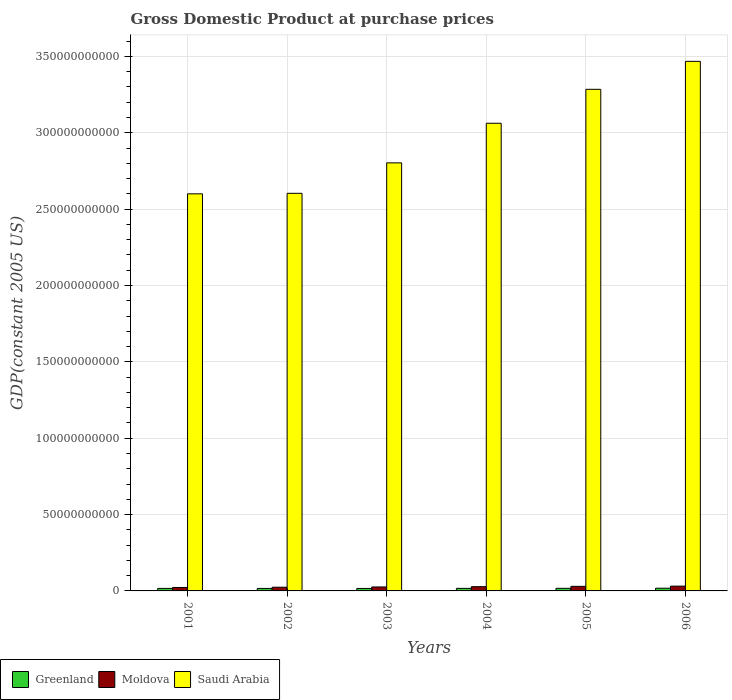How many different coloured bars are there?
Provide a succinct answer. 3. How many groups of bars are there?
Make the answer very short. 6. Are the number of bars per tick equal to the number of legend labels?
Offer a terse response. Yes. What is the label of the 3rd group of bars from the left?
Offer a terse response. 2003. In how many cases, is the number of bars for a given year not equal to the number of legend labels?
Provide a short and direct response. 0. What is the GDP at purchase prices in Moldova in 2005?
Give a very brief answer. 2.99e+09. Across all years, what is the maximum GDP at purchase prices in Saudi Arabia?
Provide a short and direct response. 3.47e+11. Across all years, what is the minimum GDP at purchase prices in Moldova?
Offer a very short reply. 2.25e+09. In which year was the GDP at purchase prices in Greenland maximum?
Offer a terse response. 2006. In which year was the GDP at purchase prices in Greenland minimum?
Provide a succinct answer. 2003. What is the total GDP at purchase prices in Saudi Arabia in the graph?
Give a very brief answer. 1.78e+12. What is the difference between the GDP at purchase prices in Saudi Arabia in 2003 and that in 2005?
Your answer should be very brief. -4.82e+1. What is the difference between the GDP at purchase prices in Greenland in 2006 and the GDP at purchase prices in Moldova in 2002?
Your answer should be compact. -6.49e+08. What is the average GDP at purchase prices in Greenland per year?
Your answer should be compact. 1.68e+09. In the year 2003, what is the difference between the GDP at purchase prices in Saudi Arabia and GDP at purchase prices in Greenland?
Provide a short and direct response. 2.79e+11. What is the ratio of the GDP at purchase prices in Moldova in 2001 to that in 2002?
Give a very brief answer. 0.93. Is the difference between the GDP at purchase prices in Saudi Arabia in 2001 and 2003 greater than the difference between the GDP at purchase prices in Greenland in 2001 and 2003?
Provide a short and direct response. No. What is the difference between the highest and the second highest GDP at purchase prices in Greenland?
Offer a very short reply. 7.61e+07. What is the difference between the highest and the lowest GDP at purchase prices in Moldova?
Offer a very short reply. 8.79e+08. In how many years, is the GDP at purchase prices in Moldova greater than the average GDP at purchase prices in Moldova taken over all years?
Ensure brevity in your answer.  3. What does the 2nd bar from the left in 2006 represents?
Your response must be concise. Moldova. What does the 2nd bar from the right in 2003 represents?
Provide a succinct answer. Moldova. How many bars are there?
Keep it short and to the point. 18. Are all the bars in the graph horizontal?
Give a very brief answer. No. How many years are there in the graph?
Keep it short and to the point. 6. Are the values on the major ticks of Y-axis written in scientific E-notation?
Ensure brevity in your answer.  No. Does the graph contain grids?
Ensure brevity in your answer.  Yes. Where does the legend appear in the graph?
Keep it short and to the point. Bottom left. How are the legend labels stacked?
Your answer should be very brief. Horizontal. What is the title of the graph?
Keep it short and to the point. Gross Domestic Product at purchase prices. Does "Iran" appear as one of the legend labels in the graph?
Give a very brief answer. No. What is the label or title of the Y-axis?
Your response must be concise. GDP(constant 2005 US). What is the GDP(constant 2005 US) of Greenland in 2001?
Give a very brief answer. 1.65e+09. What is the GDP(constant 2005 US) in Moldova in 2001?
Offer a very short reply. 2.25e+09. What is the GDP(constant 2005 US) of Saudi Arabia in 2001?
Your answer should be very brief. 2.60e+11. What is the GDP(constant 2005 US) in Greenland in 2002?
Make the answer very short. 1.63e+09. What is the GDP(constant 2005 US) in Moldova in 2002?
Make the answer very short. 2.43e+09. What is the GDP(constant 2005 US) of Saudi Arabia in 2002?
Make the answer very short. 2.60e+11. What is the GDP(constant 2005 US) of Greenland in 2003?
Your answer should be very brief. 1.63e+09. What is the GDP(constant 2005 US) of Moldova in 2003?
Ensure brevity in your answer.  2.59e+09. What is the GDP(constant 2005 US) of Saudi Arabia in 2003?
Provide a short and direct response. 2.80e+11. What is the GDP(constant 2005 US) of Greenland in 2004?
Make the answer very short. 1.67e+09. What is the GDP(constant 2005 US) of Moldova in 2004?
Your response must be concise. 2.78e+09. What is the GDP(constant 2005 US) of Saudi Arabia in 2004?
Offer a very short reply. 3.06e+11. What is the GDP(constant 2005 US) of Greenland in 2005?
Provide a short and direct response. 1.70e+09. What is the GDP(constant 2005 US) of Moldova in 2005?
Offer a very short reply. 2.99e+09. What is the GDP(constant 2005 US) of Saudi Arabia in 2005?
Your answer should be compact. 3.28e+11. What is the GDP(constant 2005 US) of Greenland in 2006?
Your response must be concise. 1.78e+09. What is the GDP(constant 2005 US) of Moldova in 2006?
Your answer should be compact. 3.13e+09. What is the GDP(constant 2005 US) in Saudi Arabia in 2006?
Make the answer very short. 3.47e+11. Across all years, what is the maximum GDP(constant 2005 US) in Greenland?
Give a very brief answer. 1.78e+09. Across all years, what is the maximum GDP(constant 2005 US) in Moldova?
Offer a very short reply. 3.13e+09. Across all years, what is the maximum GDP(constant 2005 US) in Saudi Arabia?
Ensure brevity in your answer.  3.47e+11. Across all years, what is the minimum GDP(constant 2005 US) in Greenland?
Give a very brief answer. 1.63e+09. Across all years, what is the minimum GDP(constant 2005 US) of Moldova?
Your response must be concise. 2.25e+09. Across all years, what is the minimum GDP(constant 2005 US) of Saudi Arabia?
Your answer should be very brief. 2.60e+11. What is the total GDP(constant 2005 US) in Greenland in the graph?
Your response must be concise. 1.01e+1. What is the total GDP(constant 2005 US) in Moldova in the graph?
Offer a terse response. 1.62e+1. What is the total GDP(constant 2005 US) of Saudi Arabia in the graph?
Offer a very short reply. 1.78e+12. What is the difference between the GDP(constant 2005 US) of Greenland in 2001 and that in 2002?
Provide a succinct answer. 1.60e+07. What is the difference between the GDP(constant 2005 US) in Moldova in 2001 and that in 2002?
Your answer should be compact. -1.76e+08. What is the difference between the GDP(constant 2005 US) in Saudi Arabia in 2001 and that in 2002?
Your answer should be compact. -3.32e+08. What is the difference between the GDP(constant 2005 US) in Greenland in 2001 and that in 2003?
Your response must be concise. 2.22e+07. What is the difference between the GDP(constant 2005 US) of Moldova in 2001 and that in 2003?
Provide a succinct answer. -3.36e+08. What is the difference between the GDP(constant 2005 US) in Saudi Arabia in 2001 and that in 2003?
Offer a terse response. -2.03e+1. What is the difference between the GDP(constant 2005 US) of Greenland in 2001 and that in 2004?
Offer a very short reply. -2.12e+07. What is the difference between the GDP(constant 2005 US) in Moldova in 2001 and that in 2004?
Keep it short and to the point. -5.28e+08. What is the difference between the GDP(constant 2005 US) in Saudi Arabia in 2001 and that in 2004?
Your answer should be very brief. -4.62e+1. What is the difference between the GDP(constant 2005 US) in Greenland in 2001 and that in 2005?
Your answer should be very brief. -5.42e+07. What is the difference between the GDP(constant 2005 US) of Moldova in 2001 and that in 2005?
Make the answer very short. -7.36e+08. What is the difference between the GDP(constant 2005 US) in Saudi Arabia in 2001 and that in 2005?
Offer a very short reply. -6.84e+1. What is the difference between the GDP(constant 2005 US) of Greenland in 2001 and that in 2006?
Make the answer very short. -1.30e+08. What is the difference between the GDP(constant 2005 US) in Moldova in 2001 and that in 2006?
Make the answer very short. -8.79e+08. What is the difference between the GDP(constant 2005 US) in Saudi Arabia in 2001 and that in 2006?
Provide a succinct answer. -8.68e+1. What is the difference between the GDP(constant 2005 US) in Greenland in 2002 and that in 2003?
Offer a terse response. 6.20e+06. What is the difference between the GDP(constant 2005 US) of Moldova in 2002 and that in 2003?
Ensure brevity in your answer.  -1.60e+08. What is the difference between the GDP(constant 2005 US) of Saudi Arabia in 2002 and that in 2003?
Ensure brevity in your answer.  -1.99e+1. What is the difference between the GDP(constant 2005 US) of Greenland in 2002 and that in 2004?
Your response must be concise. -3.72e+07. What is the difference between the GDP(constant 2005 US) in Moldova in 2002 and that in 2004?
Offer a very short reply. -3.52e+08. What is the difference between the GDP(constant 2005 US) of Saudi Arabia in 2002 and that in 2004?
Give a very brief answer. -4.59e+1. What is the difference between the GDP(constant 2005 US) in Greenland in 2002 and that in 2005?
Keep it short and to the point. -7.02e+07. What is the difference between the GDP(constant 2005 US) of Moldova in 2002 and that in 2005?
Provide a short and direct response. -5.60e+08. What is the difference between the GDP(constant 2005 US) of Saudi Arabia in 2002 and that in 2005?
Provide a succinct answer. -6.81e+1. What is the difference between the GDP(constant 2005 US) in Greenland in 2002 and that in 2006?
Make the answer very short. -1.46e+08. What is the difference between the GDP(constant 2005 US) in Moldova in 2002 and that in 2006?
Give a very brief answer. -7.04e+08. What is the difference between the GDP(constant 2005 US) of Saudi Arabia in 2002 and that in 2006?
Provide a short and direct response. -8.64e+1. What is the difference between the GDP(constant 2005 US) in Greenland in 2003 and that in 2004?
Ensure brevity in your answer.  -4.34e+07. What is the difference between the GDP(constant 2005 US) in Moldova in 2003 and that in 2004?
Ensure brevity in your answer.  -1.92e+08. What is the difference between the GDP(constant 2005 US) of Saudi Arabia in 2003 and that in 2004?
Keep it short and to the point. -2.59e+1. What is the difference between the GDP(constant 2005 US) in Greenland in 2003 and that in 2005?
Provide a succinct answer. -7.64e+07. What is the difference between the GDP(constant 2005 US) of Moldova in 2003 and that in 2005?
Ensure brevity in your answer.  -4.00e+08. What is the difference between the GDP(constant 2005 US) of Saudi Arabia in 2003 and that in 2005?
Your response must be concise. -4.82e+1. What is the difference between the GDP(constant 2005 US) of Greenland in 2003 and that in 2006?
Offer a terse response. -1.53e+08. What is the difference between the GDP(constant 2005 US) of Moldova in 2003 and that in 2006?
Ensure brevity in your answer.  -5.43e+08. What is the difference between the GDP(constant 2005 US) of Saudi Arabia in 2003 and that in 2006?
Provide a succinct answer. -6.65e+1. What is the difference between the GDP(constant 2005 US) in Greenland in 2004 and that in 2005?
Your answer should be very brief. -3.30e+07. What is the difference between the GDP(constant 2005 US) in Moldova in 2004 and that in 2005?
Your response must be concise. -2.08e+08. What is the difference between the GDP(constant 2005 US) in Saudi Arabia in 2004 and that in 2005?
Offer a terse response. -2.22e+1. What is the difference between the GDP(constant 2005 US) of Greenland in 2004 and that in 2006?
Offer a terse response. -1.09e+08. What is the difference between the GDP(constant 2005 US) of Moldova in 2004 and that in 2006?
Offer a very short reply. -3.52e+08. What is the difference between the GDP(constant 2005 US) in Saudi Arabia in 2004 and that in 2006?
Your answer should be compact. -4.05e+1. What is the difference between the GDP(constant 2005 US) of Greenland in 2005 and that in 2006?
Your answer should be compact. -7.61e+07. What is the difference between the GDP(constant 2005 US) in Moldova in 2005 and that in 2006?
Provide a succinct answer. -1.43e+08. What is the difference between the GDP(constant 2005 US) of Saudi Arabia in 2005 and that in 2006?
Ensure brevity in your answer.  -1.83e+1. What is the difference between the GDP(constant 2005 US) in Greenland in 2001 and the GDP(constant 2005 US) in Moldova in 2002?
Your answer should be compact. -7.80e+08. What is the difference between the GDP(constant 2005 US) of Greenland in 2001 and the GDP(constant 2005 US) of Saudi Arabia in 2002?
Ensure brevity in your answer.  -2.59e+11. What is the difference between the GDP(constant 2005 US) of Moldova in 2001 and the GDP(constant 2005 US) of Saudi Arabia in 2002?
Ensure brevity in your answer.  -2.58e+11. What is the difference between the GDP(constant 2005 US) in Greenland in 2001 and the GDP(constant 2005 US) in Moldova in 2003?
Offer a terse response. -9.40e+08. What is the difference between the GDP(constant 2005 US) of Greenland in 2001 and the GDP(constant 2005 US) of Saudi Arabia in 2003?
Your answer should be very brief. -2.79e+11. What is the difference between the GDP(constant 2005 US) in Moldova in 2001 and the GDP(constant 2005 US) in Saudi Arabia in 2003?
Your response must be concise. -2.78e+11. What is the difference between the GDP(constant 2005 US) of Greenland in 2001 and the GDP(constant 2005 US) of Moldova in 2004?
Ensure brevity in your answer.  -1.13e+09. What is the difference between the GDP(constant 2005 US) of Greenland in 2001 and the GDP(constant 2005 US) of Saudi Arabia in 2004?
Give a very brief answer. -3.05e+11. What is the difference between the GDP(constant 2005 US) in Moldova in 2001 and the GDP(constant 2005 US) in Saudi Arabia in 2004?
Your answer should be very brief. -3.04e+11. What is the difference between the GDP(constant 2005 US) in Greenland in 2001 and the GDP(constant 2005 US) in Moldova in 2005?
Your answer should be very brief. -1.34e+09. What is the difference between the GDP(constant 2005 US) of Greenland in 2001 and the GDP(constant 2005 US) of Saudi Arabia in 2005?
Offer a terse response. -3.27e+11. What is the difference between the GDP(constant 2005 US) in Moldova in 2001 and the GDP(constant 2005 US) in Saudi Arabia in 2005?
Keep it short and to the point. -3.26e+11. What is the difference between the GDP(constant 2005 US) in Greenland in 2001 and the GDP(constant 2005 US) in Moldova in 2006?
Keep it short and to the point. -1.48e+09. What is the difference between the GDP(constant 2005 US) in Greenland in 2001 and the GDP(constant 2005 US) in Saudi Arabia in 2006?
Make the answer very short. -3.45e+11. What is the difference between the GDP(constant 2005 US) of Moldova in 2001 and the GDP(constant 2005 US) of Saudi Arabia in 2006?
Provide a succinct answer. -3.45e+11. What is the difference between the GDP(constant 2005 US) in Greenland in 2002 and the GDP(constant 2005 US) in Moldova in 2003?
Your answer should be compact. -9.56e+08. What is the difference between the GDP(constant 2005 US) in Greenland in 2002 and the GDP(constant 2005 US) in Saudi Arabia in 2003?
Give a very brief answer. -2.79e+11. What is the difference between the GDP(constant 2005 US) of Moldova in 2002 and the GDP(constant 2005 US) of Saudi Arabia in 2003?
Offer a terse response. -2.78e+11. What is the difference between the GDP(constant 2005 US) in Greenland in 2002 and the GDP(constant 2005 US) in Moldova in 2004?
Keep it short and to the point. -1.15e+09. What is the difference between the GDP(constant 2005 US) in Greenland in 2002 and the GDP(constant 2005 US) in Saudi Arabia in 2004?
Ensure brevity in your answer.  -3.05e+11. What is the difference between the GDP(constant 2005 US) of Moldova in 2002 and the GDP(constant 2005 US) of Saudi Arabia in 2004?
Your answer should be very brief. -3.04e+11. What is the difference between the GDP(constant 2005 US) of Greenland in 2002 and the GDP(constant 2005 US) of Moldova in 2005?
Provide a short and direct response. -1.36e+09. What is the difference between the GDP(constant 2005 US) of Greenland in 2002 and the GDP(constant 2005 US) of Saudi Arabia in 2005?
Provide a succinct answer. -3.27e+11. What is the difference between the GDP(constant 2005 US) of Moldova in 2002 and the GDP(constant 2005 US) of Saudi Arabia in 2005?
Keep it short and to the point. -3.26e+11. What is the difference between the GDP(constant 2005 US) of Greenland in 2002 and the GDP(constant 2005 US) of Moldova in 2006?
Make the answer very short. -1.50e+09. What is the difference between the GDP(constant 2005 US) of Greenland in 2002 and the GDP(constant 2005 US) of Saudi Arabia in 2006?
Make the answer very short. -3.45e+11. What is the difference between the GDP(constant 2005 US) of Moldova in 2002 and the GDP(constant 2005 US) of Saudi Arabia in 2006?
Make the answer very short. -3.44e+11. What is the difference between the GDP(constant 2005 US) in Greenland in 2003 and the GDP(constant 2005 US) in Moldova in 2004?
Your answer should be very brief. -1.15e+09. What is the difference between the GDP(constant 2005 US) in Greenland in 2003 and the GDP(constant 2005 US) in Saudi Arabia in 2004?
Make the answer very short. -3.05e+11. What is the difference between the GDP(constant 2005 US) in Moldova in 2003 and the GDP(constant 2005 US) in Saudi Arabia in 2004?
Your response must be concise. -3.04e+11. What is the difference between the GDP(constant 2005 US) of Greenland in 2003 and the GDP(constant 2005 US) of Moldova in 2005?
Ensure brevity in your answer.  -1.36e+09. What is the difference between the GDP(constant 2005 US) of Greenland in 2003 and the GDP(constant 2005 US) of Saudi Arabia in 2005?
Your answer should be very brief. -3.27e+11. What is the difference between the GDP(constant 2005 US) of Moldova in 2003 and the GDP(constant 2005 US) of Saudi Arabia in 2005?
Give a very brief answer. -3.26e+11. What is the difference between the GDP(constant 2005 US) in Greenland in 2003 and the GDP(constant 2005 US) in Moldova in 2006?
Your answer should be compact. -1.51e+09. What is the difference between the GDP(constant 2005 US) in Greenland in 2003 and the GDP(constant 2005 US) in Saudi Arabia in 2006?
Offer a terse response. -3.45e+11. What is the difference between the GDP(constant 2005 US) of Moldova in 2003 and the GDP(constant 2005 US) of Saudi Arabia in 2006?
Offer a terse response. -3.44e+11. What is the difference between the GDP(constant 2005 US) in Greenland in 2004 and the GDP(constant 2005 US) in Moldova in 2005?
Ensure brevity in your answer.  -1.32e+09. What is the difference between the GDP(constant 2005 US) of Greenland in 2004 and the GDP(constant 2005 US) of Saudi Arabia in 2005?
Make the answer very short. -3.27e+11. What is the difference between the GDP(constant 2005 US) in Moldova in 2004 and the GDP(constant 2005 US) in Saudi Arabia in 2005?
Give a very brief answer. -3.26e+11. What is the difference between the GDP(constant 2005 US) in Greenland in 2004 and the GDP(constant 2005 US) in Moldova in 2006?
Your answer should be very brief. -1.46e+09. What is the difference between the GDP(constant 2005 US) of Greenland in 2004 and the GDP(constant 2005 US) of Saudi Arabia in 2006?
Offer a terse response. -3.45e+11. What is the difference between the GDP(constant 2005 US) in Moldova in 2004 and the GDP(constant 2005 US) in Saudi Arabia in 2006?
Your answer should be compact. -3.44e+11. What is the difference between the GDP(constant 2005 US) in Greenland in 2005 and the GDP(constant 2005 US) in Moldova in 2006?
Your response must be concise. -1.43e+09. What is the difference between the GDP(constant 2005 US) in Greenland in 2005 and the GDP(constant 2005 US) in Saudi Arabia in 2006?
Your answer should be very brief. -3.45e+11. What is the difference between the GDP(constant 2005 US) in Moldova in 2005 and the GDP(constant 2005 US) in Saudi Arabia in 2006?
Keep it short and to the point. -3.44e+11. What is the average GDP(constant 2005 US) of Greenland per year?
Your response must be concise. 1.68e+09. What is the average GDP(constant 2005 US) in Moldova per year?
Your answer should be compact. 2.69e+09. What is the average GDP(constant 2005 US) in Saudi Arabia per year?
Make the answer very short. 2.97e+11. In the year 2001, what is the difference between the GDP(constant 2005 US) in Greenland and GDP(constant 2005 US) in Moldova?
Provide a succinct answer. -6.04e+08. In the year 2001, what is the difference between the GDP(constant 2005 US) in Greenland and GDP(constant 2005 US) in Saudi Arabia?
Your answer should be very brief. -2.58e+11. In the year 2001, what is the difference between the GDP(constant 2005 US) in Moldova and GDP(constant 2005 US) in Saudi Arabia?
Offer a terse response. -2.58e+11. In the year 2002, what is the difference between the GDP(constant 2005 US) in Greenland and GDP(constant 2005 US) in Moldova?
Your answer should be compact. -7.96e+08. In the year 2002, what is the difference between the GDP(constant 2005 US) in Greenland and GDP(constant 2005 US) in Saudi Arabia?
Give a very brief answer. -2.59e+11. In the year 2002, what is the difference between the GDP(constant 2005 US) in Moldova and GDP(constant 2005 US) in Saudi Arabia?
Make the answer very short. -2.58e+11. In the year 2003, what is the difference between the GDP(constant 2005 US) of Greenland and GDP(constant 2005 US) of Moldova?
Ensure brevity in your answer.  -9.62e+08. In the year 2003, what is the difference between the GDP(constant 2005 US) in Greenland and GDP(constant 2005 US) in Saudi Arabia?
Keep it short and to the point. -2.79e+11. In the year 2003, what is the difference between the GDP(constant 2005 US) of Moldova and GDP(constant 2005 US) of Saudi Arabia?
Provide a short and direct response. -2.78e+11. In the year 2004, what is the difference between the GDP(constant 2005 US) of Greenland and GDP(constant 2005 US) of Moldova?
Your response must be concise. -1.11e+09. In the year 2004, what is the difference between the GDP(constant 2005 US) of Greenland and GDP(constant 2005 US) of Saudi Arabia?
Keep it short and to the point. -3.05e+11. In the year 2004, what is the difference between the GDP(constant 2005 US) of Moldova and GDP(constant 2005 US) of Saudi Arabia?
Make the answer very short. -3.03e+11. In the year 2005, what is the difference between the GDP(constant 2005 US) of Greenland and GDP(constant 2005 US) of Moldova?
Ensure brevity in your answer.  -1.29e+09. In the year 2005, what is the difference between the GDP(constant 2005 US) of Greenland and GDP(constant 2005 US) of Saudi Arabia?
Give a very brief answer. -3.27e+11. In the year 2005, what is the difference between the GDP(constant 2005 US) of Moldova and GDP(constant 2005 US) of Saudi Arabia?
Your response must be concise. -3.25e+11. In the year 2006, what is the difference between the GDP(constant 2005 US) of Greenland and GDP(constant 2005 US) of Moldova?
Keep it short and to the point. -1.35e+09. In the year 2006, what is the difference between the GDP(constant 2005 US) of Greenland and GDP(constant 2005 US) of Saudi Arabia?
Provide a short and direct response. -3.45e+11. In the year 2006, what is the difference between the GDP(constant 2005 US) in Moldova and GDP(constant 2005 US) in Saudi Arabia?
Offer a very short reply. -3.44e+11. What is the ratio of the GDP(constant 2005 US) in Greenland in 2001 to that in 2002?
Your answer should be compact. 1.01. What is the ratio of the GDP(constant 2005 US) of Moldova in 2001 to that in 2002?
Your response must be concise. 0.93. What is the ratio of the GDP(constant 2005 US) in Greenland in 2001 to that in 2003?
Give a very brief answer. 1.01. What is the ratio of the GDP(constant 2005 US) in Moldova in 2001 to that in 2003?
Your answer should be very brief. 0.87. What is the ratio of the GDP(constant 2005 US) of Saudi Arabia in 2001 to that in 2003?
Your answer should be compact. 0.93. What is the ratio of the GDP(constant 2005 US) of Greenland in 2001 to that in 2004?
Offer a very short reply. 0.99. What is the ratio of the GDP(constant 2005 US) of Moldova in 2001 to that in 2004?
Make the answer very short. 0.81. What is the ratio of the GDP(constant 2005 US) of Saudi Arabia in 2001 to that in 2004?
Offer a terse response. 0.85. What is the ratio of the GDP(constant 2005 US) of Greenland in 2001 to that in 2005?
Make the answer very short. 0.97. What is the ratio of the GDP(constant 2005 US) of Moldova in 2001 to that in 2005?
Keep it short and to the point. 0.75. What is the ratio of the GDP(constant 2005 US) in Saudi Arabia in 2001 to that in 2005?
Offer a terse response. 0.79. What is the ratio of the GDP(constant 2005 US) in Greenland in 2001 to that in 2006?
Provide a short and direct response. 0.93. What is the ratio of the GDP(constant 2005 US) in Moldova in 2001 to that in 2006?
Provide a short and direct response. 0.72. What is the ratio of the GDP(constant 2005 US) of Saudi Arabia in 2001 to that in 2006?
Offer a very short reply. 0.75. What is the ratio of the GDP(constant 2005 US) in Greenland in 2002 to that in 2003?
Offer a terse response. 1. What is the ratio of the GDP(constant 2005 US) in Moldova in 2002 to that in 2003?
Offer a terse response. 0.94. What is the ratio of the GDP(constant 2005 US) in Saudi Arabia in 2002 to that in 2003?
Your answer should be very brief. 0.93. What is the ratio of the GDP(constant 2005 US) in Greenland in 2002 to that in 2004?
Provide a short and direct response. 0.98. What is the ratio of the GDP(constant 2005 US) of Moldova in 2002 to that in 2004?
Your response must be concise. 0.87. What is the ratio of the GDP(constant 2005 US) in Saudi Arabia in 2002 to that in 2004?
Provide a short and direct response. 0.85. What is the ratio of the GDP(constant 2005 US) in Greenland in 2002 to that in 2005?
Make the answer very short. 0.96. What is the ratio of the GDP(constant 2005 US) in Moldova in 2002 to that in 2005?
Make the answer very short. 0.81. What is the ratio of the GDP(constant 2005 US) in Saudi Arabia in 2002 to that in 2005?
Provide a succinct answer. 0.79. What is the ratio of the GDP(constant 2005 US) of Greenland in 2002 to that in 2006?
Offer a very short reply. 0.92. What is the ratio of the GDP(constant 2005 US) of Moldova in 2002 to that in 2006?
Offer a terse response. 0.78. What is the ratio of the GDP(constant 2005 US) of Saudi Arabia in 2002 to that in 2006?
Provide a succinct answer. 0.75. What is the ratio of the GDP(constant 2005 US) in Saudi Arabia in 2003 to that in 2004?
Your answer should be very brief. 0.92. What is the ratio of the GDP(constant 2005 US) in Greenland in 2003 to that in 2005?
Provide a short and direct response. 0.96. What is the ratio of the GDP(constant 2005 US) in Moldova in 2003 to that in 2005?
Offer a very short reply. 0.87. What is the ratio of the GDP(constant 2005 US) of Saudi Arabia in 2003 to that in 2005?
Your response must be concise. 0.85. What is the ratio of the GDP(constant 2005 US) in Greenland in 2003 to that in 2006?
Your response must be concise. 0.91. What is the ratio of the GDP(constant 2005 US) of Moldova in 2003 to that in 2006?
Provide a succinct answer. 0.83. What is the ratio of the GDP(constant 2005 US) of Saudi Arabia in 2003 to that in 2006?
Your response must be concise. 0.81. What is the ratio of the GDP(constant 2005 US) of Greenland in 2004 to that in 2005?
Give a very brief answer. 0.98. What is the ratio of the GDP(constant 2005 US) in Moldova in 2004 to that in 2005?
Offer a terse response. 0.93. What is the ratio of the GDP(constant 2005 US) in Saudi Arabia in 2004 to that in 2005?
Your answer should be very brief. 0.93. What is the ratio of the GDP(constant 2005 US) in Greenland in 2004 to that in 2006?
Offer a very short reply. 0.94. What is the ratio of the GDP(constant 2005 US) of Moldova in 2004 to that in 2006?
Provide a succinct answer. 0.89. What is the ratio of the GDP(constant 2005 US) in Saudi Arabia in 2004 to that in 2006?
Your answer should be compact. 0.88. What is the ratio of the GDP(constant 2005 US) in Greenland in 2005 to that in 2006?
Offer a very short reply. 0.96. What is the ratio of the GDP(constant 2005 US) of Moldova in 2005 to that in 2006?
Ensure brevity in your answer.  0.95. What is the ratio of the GDP(constant 2005 US) of Saudi Arabia in 2005 to that in 2006?
Your response must be concise. 0.95. What is the difference between the highest and the second highest GDP(constant 2005 US) in Greenland?
Your response must be concise. 7.61e+07. What is the difference between the highest and the second highest GDP(constant 2005 US) in Moldova?
Your answer should be very brief. 1.43e+08. What is the difference between the highest and the second highest GDP(constant 2005 US) in Saudi Arabia?
Your response must be concise. 1.83e+1. What is the difference between the highest and the lowest GDP(constant 2005 US) in Greenland?
Make the answer very short. 1.53e+08. What is the difference between the highest and the lowest GDP(constant 2005 US) of Moldova?
Your answer should be compact. 8.79e+08. What is the difference between the highest and the lowest GDP(constant 2005 US) of Saudi Arabia?
Make the answer very short. 8.68e+1. 